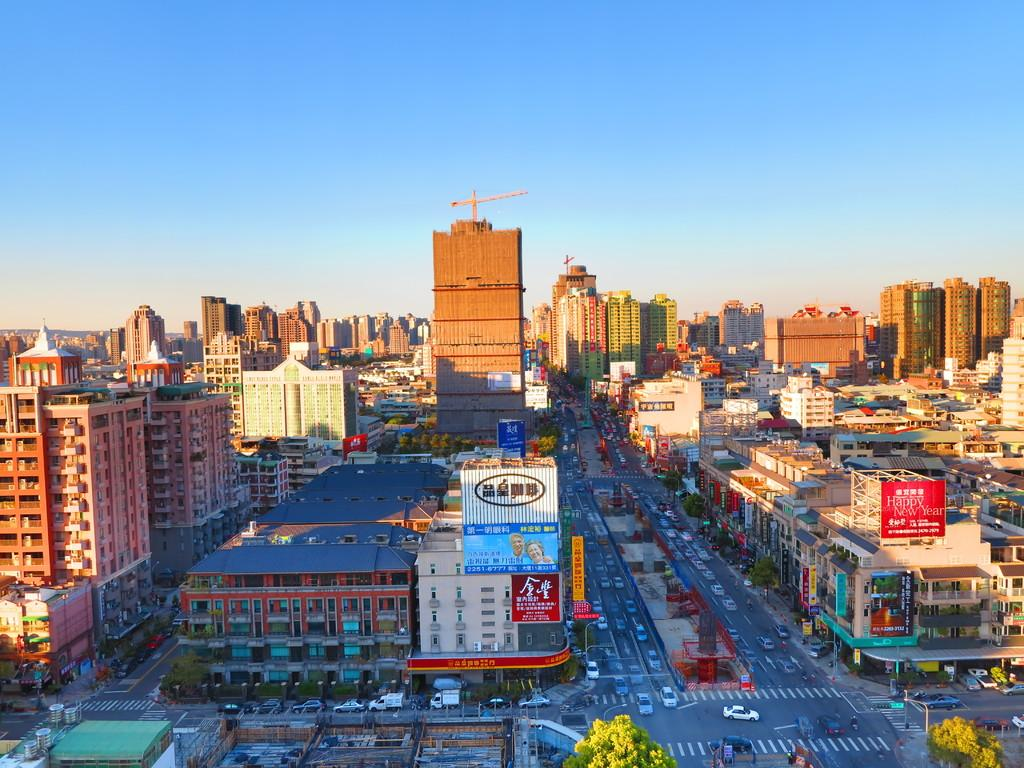What can be seen at the bottom of the image? There are buildings, trees, poles, and vehicles on the road at the bottom of the image. What is present in the sky at the top of the image? There are clouds and the sky is visible at the top of the image. What type of tank is visible on the page in the image? There is no tank or page present in the image; it features buildings, trees, poles, vehicles, clouds, and the sky. What material is the canvas made of in the image? There is no canvas present in the image. 